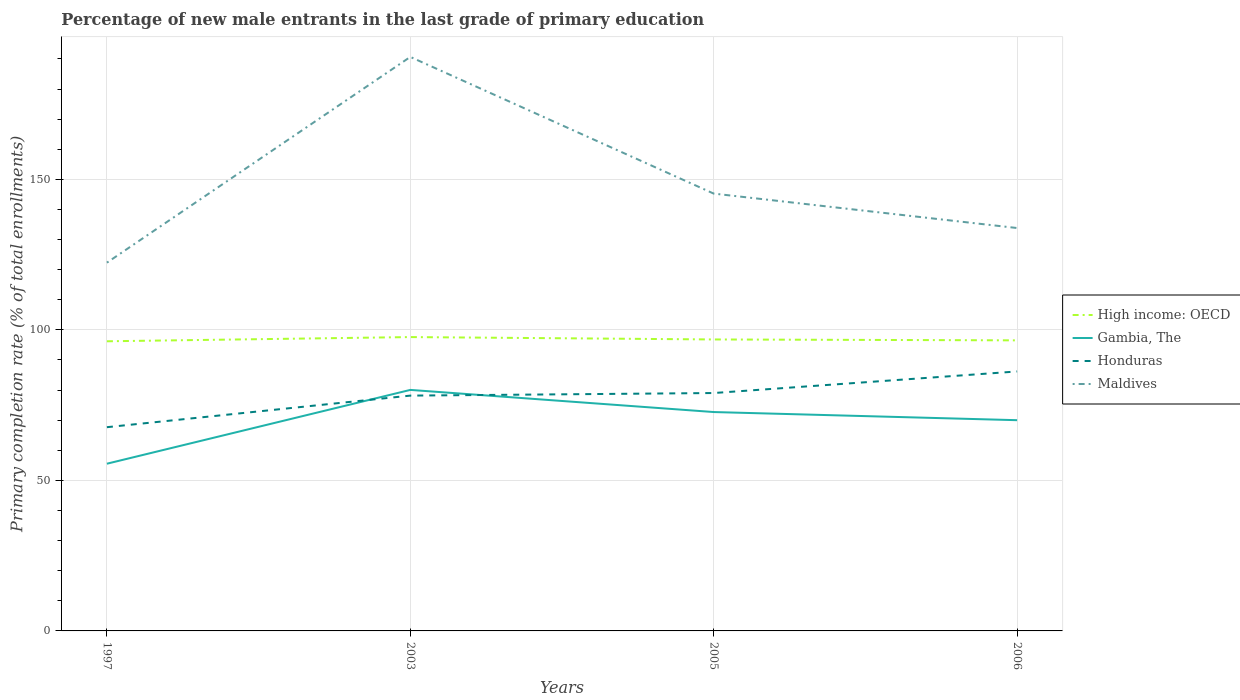Is the number of lines equal to the number of legend labels?
Offer a very short reply. Yes. Across all years, what is the maximum percentage of new male entrants in Honduras?
Your answer should be compact. 67.68. In which year was the percentage of new male entrants in Gambia, The maximum?
Your response must be concise. 1997. What is the total percentage of new male entrants in High income: OECD in the graph?
Make the answer very short. 1.09. What is the difference between the highest and the second highest percentage of new male entrants in Gambia, The?
Provide a succinct answer. 24.52. What is the difference between the highest and the lowest percentage of new male entrants in Gambia, The?
Your answer should be very brief. 3. Is the percentage of new male entrants in High income: OECD strictly greater than the percentage of new male entrants in Honduras over the years?
Provide a succinct answer. No. Are the values on the major ticks of Y-axis written in scientific E-notation?
Offer a terse response. No. How many legend labels are there?
Keep it short and to the point. 4. What is the title of the graph?
Keep it short and to the point. Percentage of new male entrants in the last grade of primary education. Does "Uganda" appear as one of the legend labels in the graph?
Keep it short and to the point. No. What is the label or title of the Y-axis?
Provide a short and direct response. Primary completion rate (% of total enrollments). What is the Primary completion rate (% of total enrollments) of High income: OECD in 1997?
Provide a short and direct response. 96.22. What is the Primary completion rate (% of total enrollments) of Gambia, The in 1997?
Ensure brevity in your answer.  55.55. What is the Primary completion rate (% of total enrollments) in Honduras in 1997?
Give a very brief answer. 67.68. What is the Primary completion rate (% of total enrollments) of Maldives in 1997?
Provide a short and direct response. 122.33. What is the Primary completion rate (% of total enrollments) in High income: OECD in 2003?
Your response must be concise. 97.62. What is the Primary completion rate (% of total enrollments) in Gambia, The in 2003?
Make the answer very short. 80.06. What is the Primary completion rate (% of total enrollments) of Honduras in 2003?
Give a very brief answer. 78.17. What is the Primary completion rate (% of total enrollments) of Maldives in 2003?
Keep it short and to the point. 190.68. What is the Primary completion rate (% of total enrollments) in High income: OECD in 2005?
Provide a succinct answer. 96.82. What is the Primary completion rate (% of total enrollments) of Gambia, The in 2005?
Make the answer very short. 72.71. What is the Primary completion rate (% of total enrollments) of Honduras in 2005?
Your response must be concise. 79.03. What is the Primary completion rate (% of total enrollments) in Maldives in 2005?
Keep it short and to the point. 145.27. What is the Primary completion rate (% of total enrollments) in High income: OECD in 2006?
Provide a succinct answer. 96.52. What is the Primary completion rate (% of total enrollments) in Gambia, The in 2006?
Your answer should be very brief. 70.01. What is the Primary completion rate (% of total enrollments) in Honduras in 2006?
Give a very brief answer. 86.19. What is the Primary completion rate (% of total enrollments) in Maldives in 2006?
Ensure brevity in your answer.  133.84. Across all years, what is the maximum Primary completion rate (% of total enrollments) of High income: OECD?
Offer a very short reply. 97.62. Across all years, what is the maximum Primary completion rate (% of total enrollments) of Gambia, The?
Offer a terse response. 80.06. Across all years, what is the maximum Primary completion rate (% of total enrollments) in Honduras?
Your answer should be very brief. 86.19. Across all years, what is the maximum Primary completion rate (% of total enrollments) in Maldives?
Ensure brevity in your answer.  190.68. Across all years, what is the minimum Primary completion rate (% of total enrollments) of High income: OECD?
Provide a succinct answer. 96.22. Across all years, what is the minimum Primary completion rate (% of total enrollments) of Gambia, The?
Offer a terse response. 55.55. Across all years, what is the minimum Primary completion rate (% of total enrollments) of Honduras?
Your answer should be compact. 67.68. Across all years, what is the minimum Primary completion rate (% of total enrollments) of Maldives?
Give a very brief answer. 122.33. What is the total Primary completion rate (% of total enrollments) of High income: OECD in the graph?
Provide a short and direct response. 387.18. What is the total Primary completion rate (% of total enrollments) in Gambia, The in the graph?
Your answer should be very brief. 278.32. What is the total Primary completion rate (% of total enrollments) of Honduras in the graph?
Keep it short and to the point. 311.07. What is the total Primary completion rate (% of total enrollments) of Maldives in the graph?
Your response must be concise. 592.13. What is the difference between the Primary completion rate (% of total enrollments) in High income: OECD in 1997 and that in 2003?
Ensure brevity in your answer.  -1.4. What is the difference between the Primary completion rate (% of total enrollments) in Gambia, The in 1997 and that in 2003?
Your answer should be very brief. -24.52. What is the difference between the Primary completion rate (% of total enrollments) in Honduras in 1997 and that in 2003?
Make the answer very short. -10.49. What is the difference between the Primary completion rate (% of total enrollments) in Maldives in 1997 and that in 2003?
Give a very brief answer. -68.35. What is the difference between the Primary completion rate (% of total enrollments) of High income: OECD in 1997 and that in 2005?
Your answer should be very brief. -0.61. What is the difference between the Primary completion rate (% of total enrollments) of Gambia, The in 1997 and that in 2005?
Make the answer very short. -17.17. What is the difference between the Primary completion rate (% of total enrollments) in Honduras in 1997 and that in 2005?
Keep it short and to the point. -11.35. What is the difference between the Primary completion rate (% of total enrollments) in Maldives in 1997 and that in 2005?
Offer a terse response. -22.94. What is the difference between the Primary completion rate (% of total enrollments) of High income: OECD in 1997 and that in 2006?
Your response must be concise. -0.31. What is the difference between the Primary completion rate (% of total enrollments) of Gambia, The in 1997 and that in 2006?
Provide a succinct answer. -14.46. What is the difference between the Primary completion rate (% of total enrollments) of Honduras in 1997 and that in 2006?
Your response must be concise. -18.52. What is the difference between the Primary completion rate (% of total enrollments) of Maldives in 1997 and that in 2006?
Keep it short and to the point. -11.5. What is the difference between the Primary completion rate (% of total enrollments) in High income: OECD in 2003 and that in 2005?
Give a very brief answer. 0.79. What is the difference between the Primary completion rate (% of total enrollments) of Gambia, The in 2003 and that in 2005?
Your answer should be very brief. 7.35. What is the difference between the Primary completion rate (% of total enrollments) in Honduras in 2003 and that in 2005?
Your answer should be compact. -0.86. What is the difference between the Primary completion rate (% of total enrollments) in Maldives in 2003 and that in 2005?
Offer a very short reply. 45.41. What is the difference between the Primary completion rate (% of total enrollments) in High income: OECD in 2003 and that in 2006?
Ensure brevity in your answer.  1.09. What is the difference between the Primary completion rate (% of total enrollments) in Gambia, The in 2003 and that in 2006?
Provide a short and direct response. 10.06. What is the difference between the Primary completion rate (% of total enrollments) of Honduras in 2003 and that in 2006?
Your answer should be very brief. -8.02. What is the difference between the Primary completion rate (% of total enrollments) in Maldives in 2003 and that in 2006?
Your answer should be very brief. 56.84. What is the difference between the Primary completion rate (% of total enrollments) of High income: OECD in 2005 and that in 2006?
Provide a short and direct response. 0.3. What is the difference between the Primary completion rate (% of total enrollments) of Gambia, The in 2005 and that in 2006?
Offer a very short reply. 2.71. What is the difference between the Primary completion rate (% of total enrollments) in Honduras in 2005 and that in 2006?
Provide a succinct answer. -7.17. What is the difference between the Primary completion rate (% of total enrollments) of Maldives in 2005 and that in 2006?
Ensure brevity in your answer.  11.44. What is the difference between the Primary completion rate (% of total enrollments) of High income: OECD in 1997 and the Primary completion rate (% of total enrollments) of Gambia, The in 2003?
Keep it short and to the point. 16.15. What is the difference between the Primary completion rate (% of total enrollments) of High income: OECD in 1997 and the Primary completion rate (% of total enrollments) of Honduras in 2003?
Ensure brevity in your answer.  18.05. What is the difference between the Primary completion rate (% of total enrollments) of High income: OECD in 1997 and the Primary completion rate (% of total enrollments) of Maldives in 2003?
Offer a terse response. -94.46. What is the difference between the Primary completion rate (% of total enrollments) in Gambia, The in 1997 and the Primary completion rate (% of total enrollments) in Honduras in 2003?
Your answer should be very brief. -22.62. What is the difference between the Primary completion rate (% of total enrollments) of Gambia, The in 1997 and the Primary completion rate (% of total enrollments) of Maldives in 2003?
Make the answer very short. -135.13. What is the difference between the Primary completion rate (% of total enrollments) in Honduras in 1997 and the Primary completion rate (% of total enrollments) in Maldives in 2003?
Give a very brief answer. -123. What is the difference between the Primary completion rate (% of total enrollments) in High income: OECD in 1997 and the Primary completion rate (% of total enrollments) in Gambia, The in 2005?
Provide a succinct answer. 23.51. What is the difference between the Primary completion rate (% of total enrollments) of High income: OECD in 1997 and the Primary completion rate (% of total enrollments) of Honduras in 2005?
Give a very brief answer. 17.19. What is the difference between the Primary completion rate (% of total enrollments) of High income: OECD in 1997 and the Primary completion rate (% of total enrollments) of Maldives in 2005?
Offer a terse response. -49.06. What is the difference between the Primary completion rate (% of total enrollments) in Gambia, The in 1997 and the Primary completion rate (% of total enrollments) in Honduras in 2005?
Give a very brief answer. -23.48. What is the difference between the Primary completion rate (% of total enrollments) of Gambia, The in 1997 and the Primary completion rate (% of total enrollments) of Maldives in 2005?
Keep it short and to the point. -89.73. What is the difference between the Primary completion rate (% of total enrollments) of Honduras in 1997 and the Primary completion rate (% of total enrollments) of Maldives in 2005?
Make the answer very short. -77.6. What is the difference between the Primary completion rate (% of total enrollments) in High income: OECD in 1997 and the Primary completion rate (% of total enrollments) in Gambia, The in 2006?
Keep it short and to the point. 26.21. What is the difference between the Primary completion rate (% of total enrollments) in High income: OECD in 1997 and the Primary completion rate (% of total enrollments) in Honduras in 2006?
Make the answer very short. 10.02. What is the difference between the Primary completion rate (% of total enrollments) of High income: OECD in 1997 and the Primary completion rate (% of total enrollments) of Maldives in 2006?
Your response must be concise. -37.62. What is the difference between the Primary completion rate (% of total enrollments) in Gambia, The in 1997 and the Primary completion rate (% of total enrollments) in Honduras in 2006?
Ensure brevity in your answer.  -30.65. What is the difference between the Primary completion rate (% of total enrollments) of Gambia, The in 1997 and the Primary completion rate (% of total enrollments) of Maldives in 2006?
Ensure brevity in your answer.  -78.29. What is the difference between the Primary completion rate (% of total enrollments) in Honduras in 1997 and the Primary completion rate (% of total enrollments) in Maldives in 2006?
Keep it short and to the point. -66.16. What is the difference between the Primary completion rate (% of total enrollments) in High income: OECD in 2003 and the Primary completion rate (% of total enrollments) in Gambia, The in 2005?
Provide a short and direct response. 24.91. What is the difference between the Primary completion rate (% of total enrollments) in High income: OECD in 2003 and the Primary completion rate (% of total enrollments) in Honduras in 2005?
Offer a very short reply. 18.59. What is the difference between the Primary completion rate (% of total enrollments) of High income: OECD in 2003 and the Primary completion rate (% of total enrollments) of Maldives in 2005?
Make the answer very short. -47.66. What is the difference between the Primary completion rate (% of total enrollments) of Gambia, The in 2003 and the Primary completion rate (% of total enrollments) of Honduras in 2005?
Make the answer very short. 1.04. What is the difference between the Primary completion rate (% of total enrollments) in Gambia, The in 2003 and the Primary completion rate (% of total enrollments) in Maldives in 2005?
Provide a short and direct response. -65.21. What is the difference between the Primary completion rate (% of total enrollments) in Honduras in 2003 and the Primary completion rate (% of total enrollments) in Maldives in 2005?
Keep it short and to the point. -67.11. What is the difference between the Primary completion rate (% of total enrollments) of High income: OECD in 2003 and the Primary completion rate (% of total enrollments) of Gambia, The in 2006?
Your answer should be very brief. 27.61. What is the difference between the Primary completion rate (% of total enrollments) of High income: OECD in 2003 and the Primary completion rate (% of total enrollments) of Honduras in 2006?
Keep it short and to the point. 11.42. What is the difference between the Primary completion rate (% of total enrollments) of High income: OECD in 2003 and the Primary completion rate (% of total enrollments) of Maldives in 2006?
Your response must be concise. -36.22. What is the difference between the Primary completion rate (% of total enrollments) in Gambia, The in 2003 and the Primary completion rate (% of total enrollments) in Honduras in 2006?
Offer a terse response. -6.13. What is the difference between the Primary completion rate (% of total enrollments) in Gambia, The in 2003 and the Primary completion rate (% of total enrollments) in Maldives in 2006?
Your answer should be very brief. -53.77. What is the difference between the Primary completion rate (% of total enrollments) of Honduras in 2003 and the Primary completion rate (% of total enrollments) of Maldives in 2006?
Offer a terse response. -55.67. What is the difference between the Primary completion rate (% of total enrollments) in High income: OECD in 2005 and the Primary completion rate (% of total enrollments) in Gambia, The in 2006?
Your answer should be compact. 26.82. What is the difference between the Primary completion rate (% of total enrollments) in High income: OECD in 2005 and the Primary completion rate (% of total enrollments) in Honduras in 2006?
Ensure brevity in your answer.  10.63. What is the difference between the Primary completion rate (% of total enrollments) in High income: OECD in 2005 and the Primary completion rate (% of total enrollments) in Maldives in 2006?
Ensure brevity in your answer.  -37.02. What is the difference between the Primary completion rate (% of total enrollments) of Gambia, The in 2005 and the Primary completion rate (% of total enrollments) of Honduras in 2006?
Your answer should be compact. -13.48. What is the difference between the Primary completion rate (% of total enrollments) in Gambia, The in 2005 and the Primary completion rate (% of total enrollments) in Maldives in 2006?
Provide a short and direct response. -61.13. What is the difference between the Primary completion rate (% of total enrollments) in Honduras in 2005 and the Primary completion rate (% of total enrollments) in Maldives in 2006?
Your answer should be compact. -54.81. What is the average Primary completion rate (% of total enrollments) of High income: OECD per year?
Provide a succinct answer. 96.79. What is the average Primary completion rate (% of total enrollments) in Gambia, The per year?
Offer a terse response. 69.58. What is the average Primary completion rate (% of total enrollments) in Honduras per year?
Offer a terse response. 77.77. What is the average Primary completion rate (% of total enrollments) of Maldives per year?
Your answer should be very brief. 148.03. In the year 1997, what is the difference between the Primary completion rate (% of total enrollments) of High income: OECD and Primary completion rate (% of total enrollments) of Gambia, The?
Your answer should be compact. 40.67. In the year 1997, what is the difference between the Primary completion rate (% of total enrollments) in High income: OECD and Primary completion rate (% of total enrollments) in Honduras?
Your response must be concise. 28.54. In the year 1997, what is the difference between the Primary completion rate (% of total enrollments) in High income: OECD and Primary completion rate (% of total enrollments) in Maldives?
Keep it short and to the point. -26.12. In the year 1997, what is the difference between the Primary completion rate (% of total enrollments) in Gambia, The and Primary completion rate (% of total enrollments) in Honduras?
Your answer should be compact. -12.13. In the year 1997, what is the difference between the Primary completion rate (% of total enrollments) in Gambia, The and Primary completion rate (% of total enrollments) in Maldives?
Give a very brief answer. -66.79. In the year 1997, what is the difference between the Primary completion rate (% of total enrollments) of Honduras and Primary completion rate (% of total enrollments) of Maldives?
Provide a short and direct response. -54.66. In the year 2003, what is the difference between the Primary completion rate (% of total enrollments) of High income: OECD and Primary completion rate (% of total enrollments) of Gambia, The?
Provide a succinct answer. 17.55. In the year 2003, what is the difference between the Primary completion rate (% of total enrollments) in High income: OECD and Primary completion rate (% of total enrollments) in Honduras?
Offer a very short reply. 19.45. In the year 2003, what is the difference between the Primary completion rate (% of total enrollments) of High income: OECD and Primary completion rate (% of total enrollments) of Maldives?
Keep it short and to the point. -93.06. In the year 2003, what is the difference between the Primary completion rate (% of total enrollments) of Gambia, The and Primary completion rate (% of total enrollments) of Honduras?
Offer a terse response. 1.9. In the year 2003, what is the difference between the Primary completion rate (% of total enrollments) in Gambia, The and Primary completion rate (% of total enrollments) in Maldives?
Your answer should be compact. -110.62. In the year 2003, what is the difference between the Primary completion rate (% of total enrollments) in Honduras and Primary completion rate (% of total enrollments) in Maldives?
Keep it short and to the point. -112.51. In the year 2005, what is the difference between the Primary completion rate (% of total enrollments) in High income: OECD and Primary completion rate (% of total enrollments) in Gambia, The?
Make the answer very short. 24.11. In the year 2005, what is the difference between the Primary completion rate (% of total enrollments) of High income: OECD and Primary completion rate (% of total enrollments) of Honduras?
Your answer should be compact. 17.8. In the year 2005, what is the difference between the Primary completion rate (% of total enrollments) of High income: OECD and Primary completion rate (% of total enrollments) of Maldives?
Your answer should be compact. -48.45. In the year 2005, what is the difference between the Primary completion rate (% of total enrollments) in Gambia, The and Primary completion rate (% of total enrollments) in Honduras?
Your response must be concise. -6.32. In the year 2005, what is the difference between the Primary completion rate (% of total enrollments) of Gambia, The and Primary completion rate (% of total enrollments) of Maldives?
Keep it short and to the point. -72.56. In the year 2005, what is the difference between the Primary completion rate (% of total enrollments) in Honduras and Primary completion rate (% of total enrollments) in Maldives?
Your answer should be very brief. -66.25. In the year 2006, what is the difference between the Primary completion rate (% of total enrollments) of High income: OECD and Primary completion rate (% of total enrollments) of Gambia, The?
Keep it short and to the point. 26.52. In the year 2006, what is the difference between the Primary completion rate (% of total enrollments) of High income: OECD and Primary completion rate (% of total enrollments) of Honduras?
Make the answer very short. 10.33. In the year 2006, what is the difference between the Primary completion rate (% of total enrollments) in High income: OECD and Primary completion rate (% of total enrollments) in Maldives?
Provide a succinct answer. -37.32. In the year 2006, what is the difference between the Primary completion rate (% of total enrollments) in Gambia, The and Primary completion rate (% of total enrollments) in Honduras?
Give a very brief answer. -16.19. In the year 2006, what is the difference between the Primary completion rate (% of total enrollments) in Gambia, The and Primary completion rate (% of total enrollments) in Maldives?
Your answer should be very brief. -63.83. In the year 2006, what is the difference between the Primary completion rate (% of total enrollments) of Honduras and Primary completion rate (% of total enrollments) of Maldives?
Give a very brief answer. -47.65. What is the ratio of the Primary completion rate (% of total enrollments) in High income: OECD in 1997 to that in 2003?
Your answer should be very brief. 0.99. What is the ratio of the Primary completion rate (% of total enrollments) in Gambia, The in 1997 to that in 2003?
Offer a very short reply. 0.69. What is the ratio of the Primary completion rate (% of total enrollments) of Honduras in 1997 to that in 2003?
Your response must be concise. 0.87. What is the ratio of the Primary completion rate (% of total enrollments) in Maldives in 1997 to that in 2003?
Offer a very short reply. 0.64. What is the ratio of the Primary completion rate (% of total enrollments) in Gambia, The in 1997 to that in 2005?
Your answer should be very brief. 0.76. What is the ratio of the Primary completion rate (% of total enrollments) in Honduras in 1997 to that in 2005?
Give a very brief answer. 0.86. What is the ratio of the Primary completion rate (% of total enrollments) of Maldives in 1997 to that in 2005?
Offer a terse response. 0.84. What is the ratio of the Primary completion rate (% of total enrollments) of High income: OECD in 1997 to that in 2006?
Your answer should be compact. 1. What is the ratio of the Primary completion rate (% of total enrollments) of Gambia, The in 1997 to that in 2006?
Ensure brevity in your answer.  0.79. What is the ratio of the Primary completion rate (% of total enrollments) in Honduras in 1997 to that in 2006?
Ensure brevity in your answer.  0.79. What is the ratio of the Primary completion rate (% of total enrollments) in Maldives in 1997 to that in 2006?
Your answer should be very brief. 0.91. What is the ratio of the Primary completion rate (% of total enrollments) in High income: OECD in 2003 to that in 2005?
Your response must be concise. 1.01. What is the ratio of the Primary completion rate (% of total enrollments) in Gambia, The in 2003 to that in 2005?
Your answer should be compact. 1.1. What is the ratio of the Primary completion rate (% of total enrollments) of Honduras in 2003 to that in 2005?
Your answer should be compact. 0.99. What is the ratio of the Primary completion rate (% of total enrollments) of Maldives in 2003 to that in 2005?
Make the answer very short. 1.31. What is the ratio of the Primary completion rate (% of total enrollments) in High income: OECD in 2003 to that in 2006?
Offer a very short reply. 1.01. What is the ratio of the Primary completion rate (% of total enrollments) of Gambia, The in 2003 to that in 2006?
Make the answer very short. 1.14. What is the ratio of the Primary completion rate (% of total enrollments) of Honduras in 2003 to that in 2006?
Give a very brief answer. 0.91. What is the ratio of the Primary completion rate (% of total enrollments) in Maldives in 2003 to that in 2006?
Keep it short and to the point. 1.42. What is the ratio of the Primary completion rate (% of total enrollments) of Gambia, The in 2005 to that in 2006?
Your answer should be compact. 1.04. What is the ratio of the Primary completion rate (% of total enrollments) of Honduras in 2005 to that in 2006?
Keep it short and to the point. 0.92. What is the ratio of the Primary completion rate (% of total enrollments) of Maldives in 2005 to that in 2006?
Keep it short and to the point. 1.09. What is the difference between the highest and the second highest Primary completion rate (% of total enrollments) in High income: OECD?
Provide a short and direct response. 0.79. What is the difference between the highest and the second highest Primary completion rate (% of total enrollments) in Gambia, The?
Your response must be concise. 7.35. What is the difference between the highest and the second highest Primary completion rate (% of total enrollments) of Honduras?
Offer a very short reply. 7.17. What is the difference between the highest and the second highest Primary completion rate (% of total enrollments) of Maldives?
Your response must be concise. 45.41. What is the difference between the highest and the lowest Primary completion rate (% of total enrollments) of High income: OECD?
Make the answer very short. 1.4. What is the difference between the highest and the lowest Primary completion rate (% of total enrollments) in Gambia, The?
Your answer should be very brief. 24.52. What is the difference between the highest and the lowest Primary completion rate (% of total enrollments) of Honduras?
Offer a terse response. 18.52. What is the difference between the highest and the lowest Primary completion rate (% of total enrollments) in Maldives?
Your answer should be compact. 68.35. 